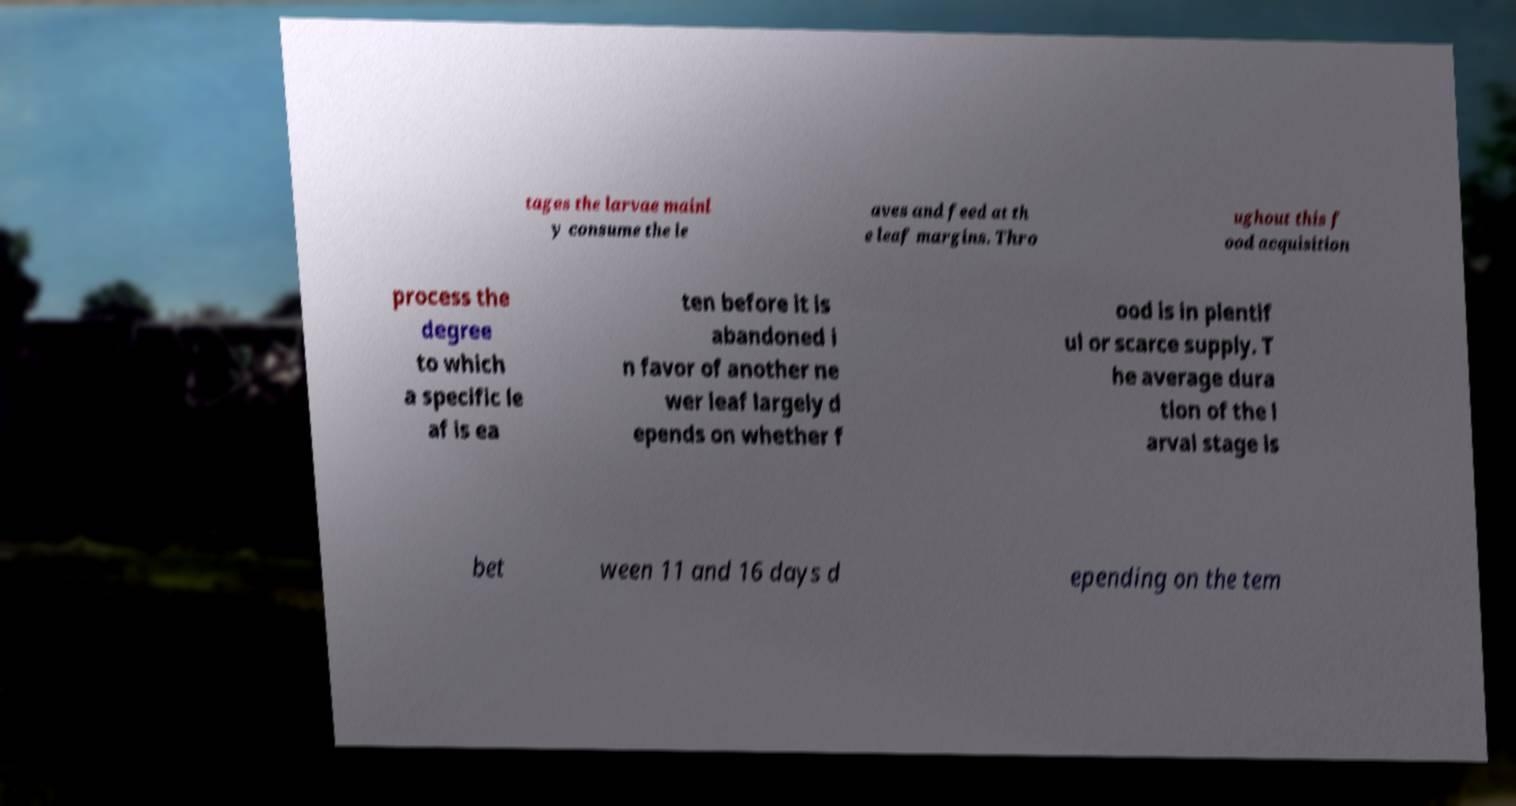Can you read and provide the text displayed in the image?This photo seems to have some interesting text. Can you extract and type it out for me? tages the larvae mainl y consume the le aves and feed at th e leaf margins. Thro ughout this f ood acquisition process the degree to which a specific le af is ea ten before it is abandoned i n favor of another ne wer leaf largely d epends on whether f ood is in plentif ul or scarce supply. T he average dura tion of the l arval stage is bet ween 11 and 16 days d epending on the tem 